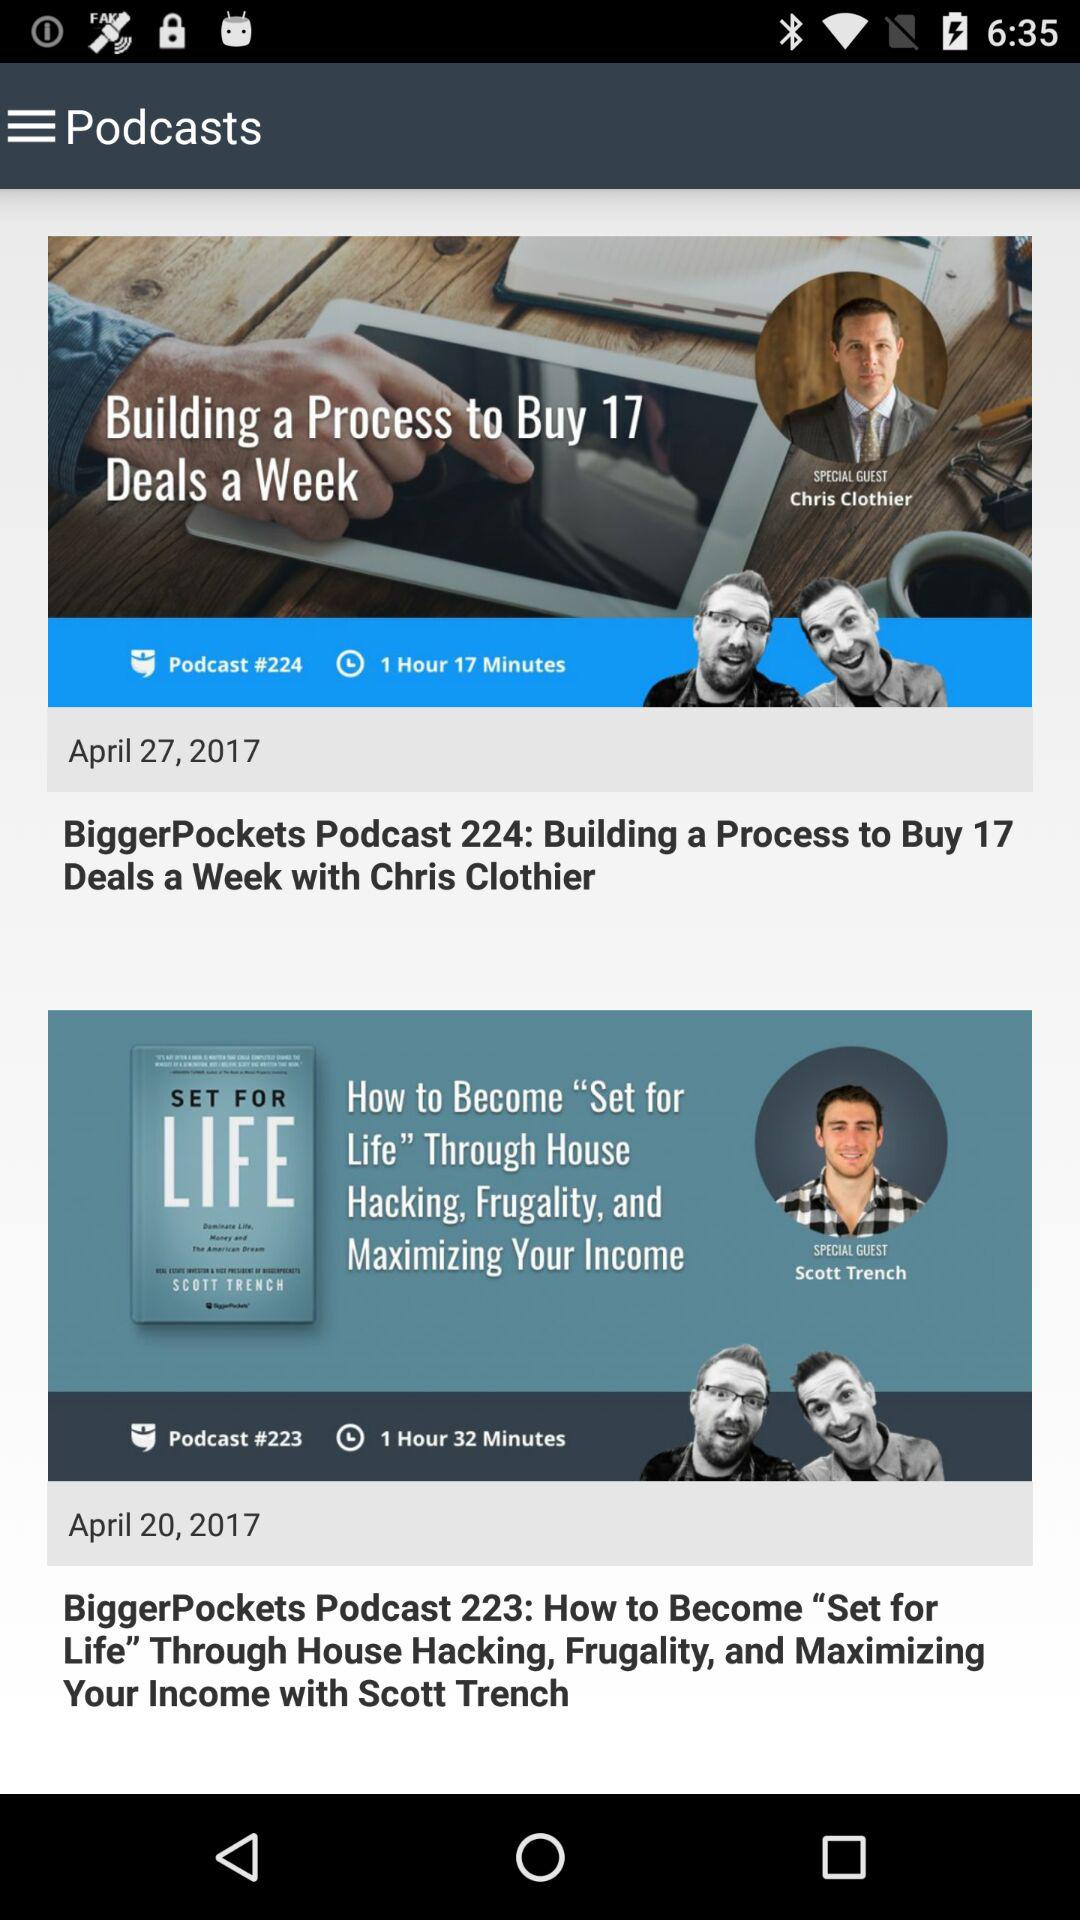When was the "BiggerPockets Podcast 223" posted? The "BiggerPockets Podcast 223" was posted on April 20, 2017. 